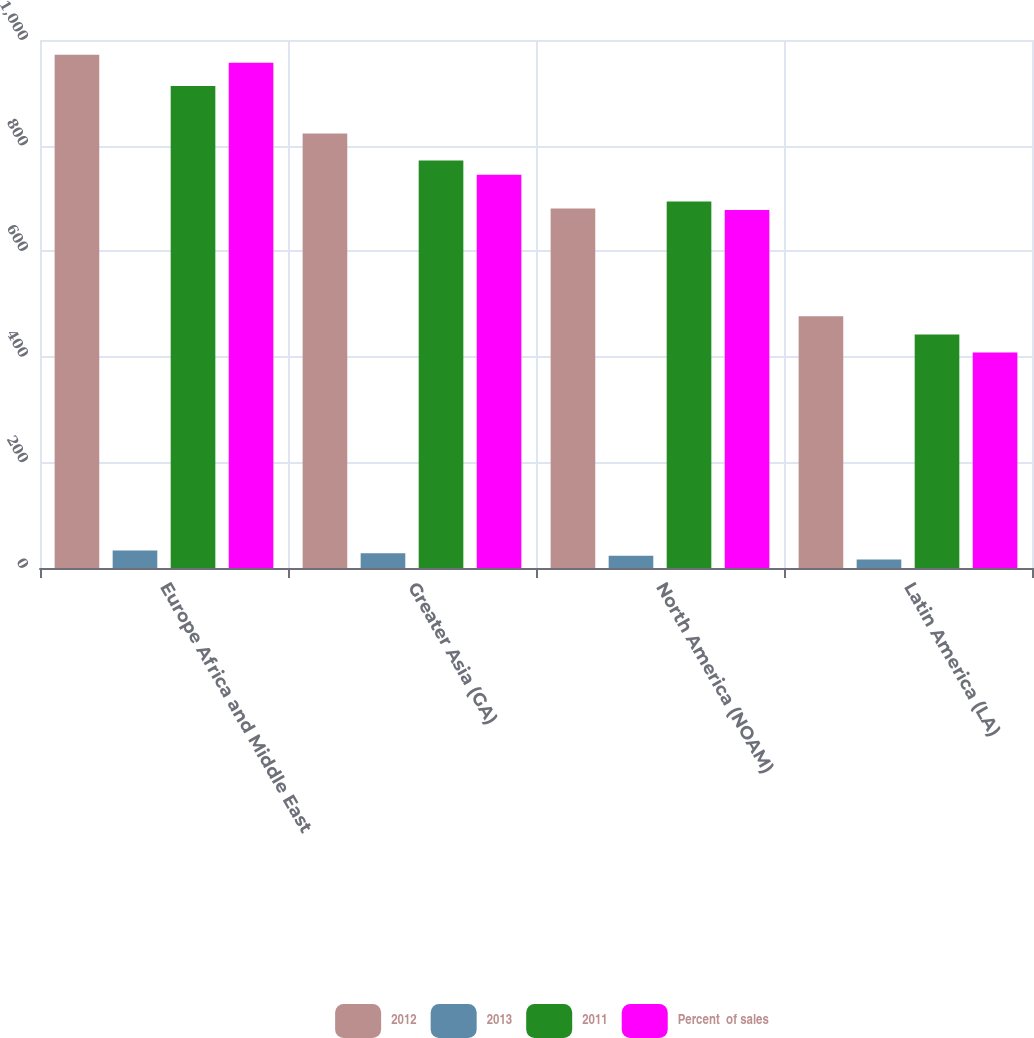Convert chart to OTSL. <chart><loc_0><loc_0><loc_500><loc_500><stacked_bar_chart><ecel><fcel>Europe Africa and Middle East<fcel>Greater Asia (GA)<fcel>North America (NOAM)<fcel>Latin America (LA)<nl><fcel>2012<fcel>972<fcel>823<fcel>681<fcel>477<nl><fcel>2013<fcel>33<fcel>28<fcel>23<fcel>16<nl><fcel>2011<fcel>913<fcel>772<fcel>694<fcel>442<nl><fcel>Percent  of sales<fcel>957<fcel>745<fcel>678<fcel>408<nl></chart> 